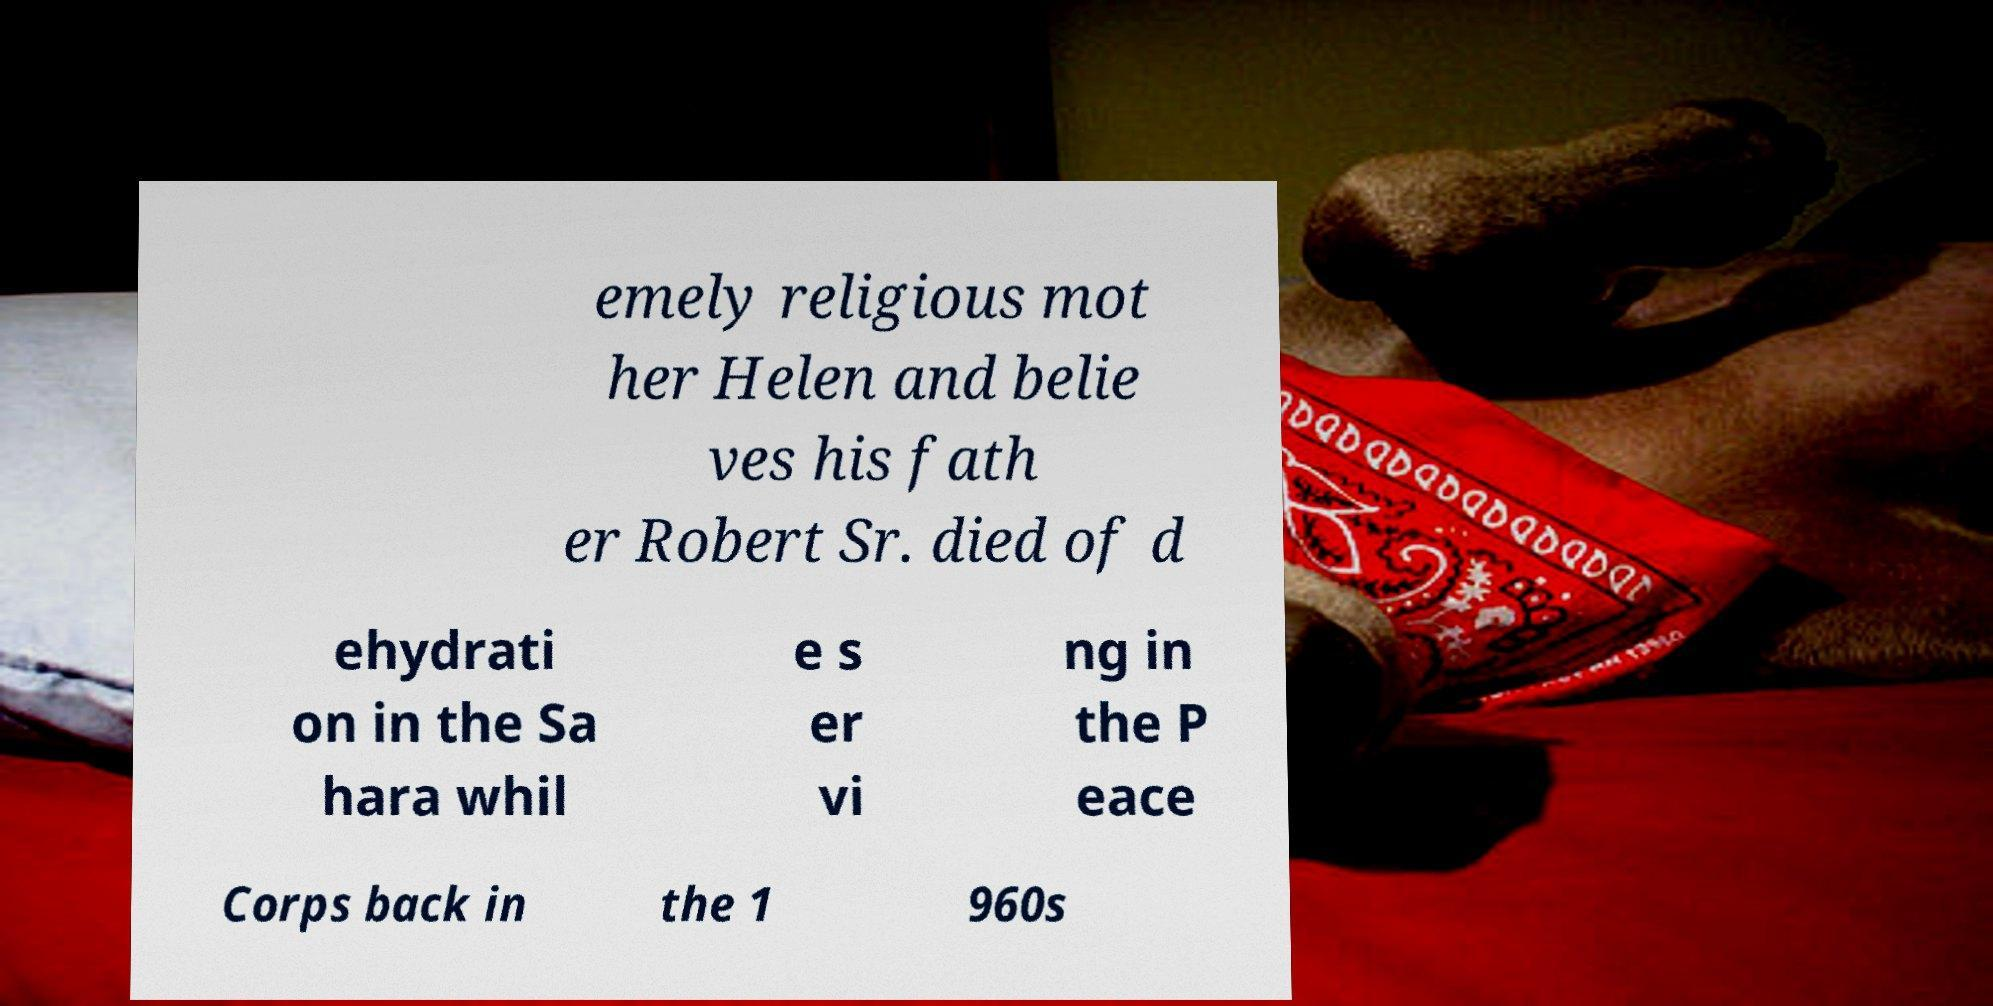Please identify and transcribe the text found in this image. emely religious mot her Helen and belie ves his fath er Robert Sr. died of d ehydrati on in the Sa hara whil e s er vi ng in the P eace Corps back in the 1 960s 